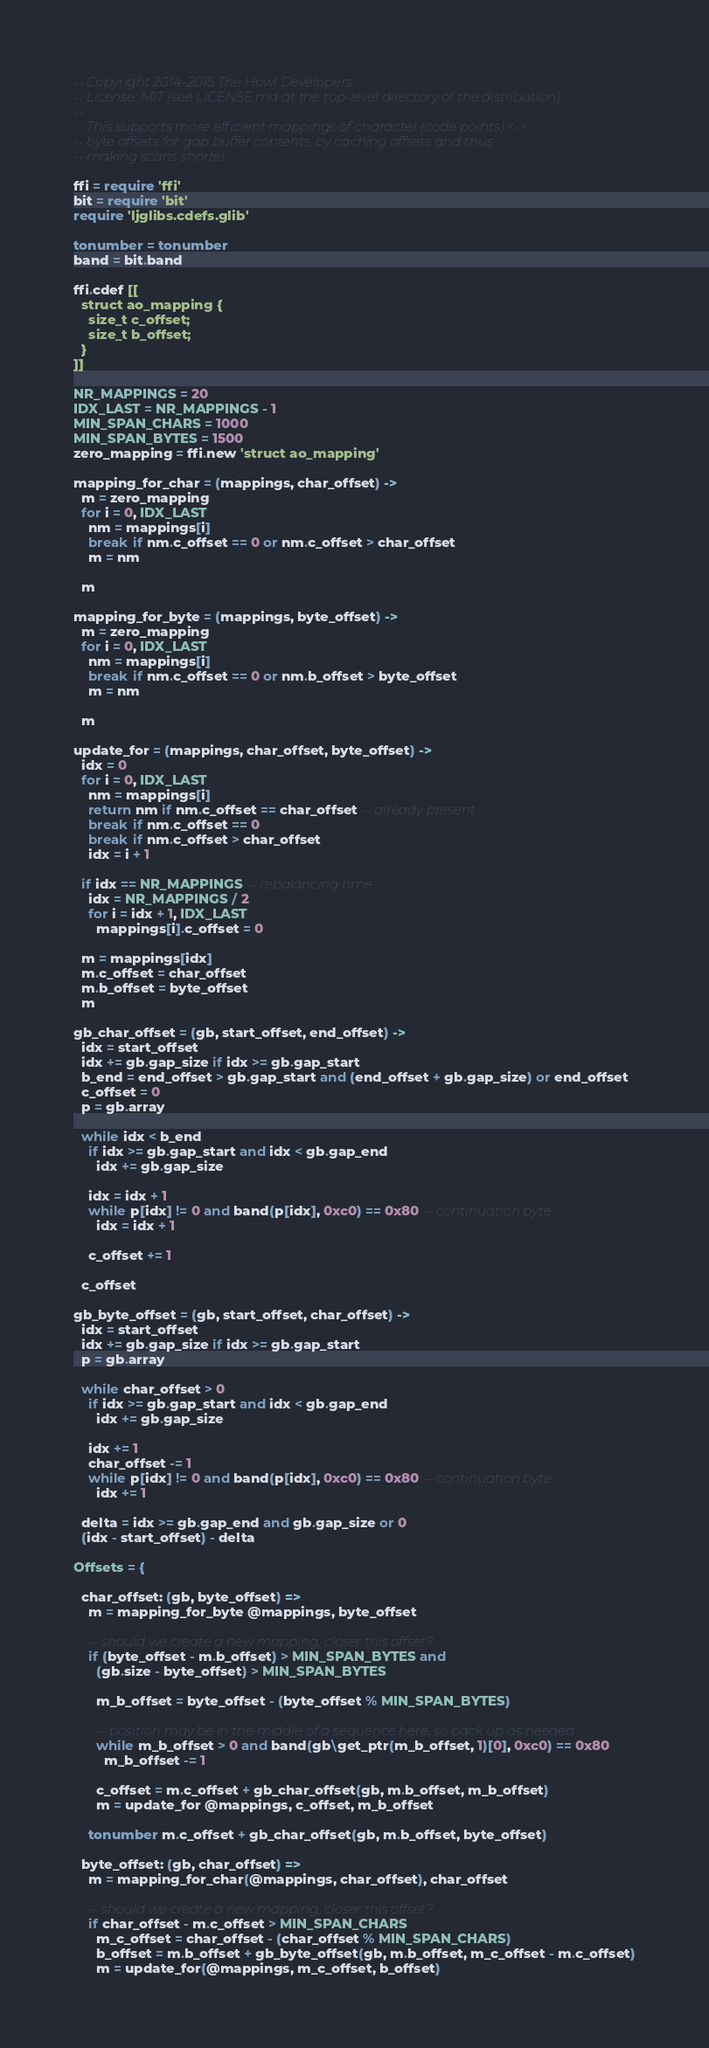<code> <loc_0><loc_0><loc_500><loc_500><_MoonScript_>-- Copyright 2014-2015 The Howl Developers
-- License: MIT (see LICENSE.md at the top-level directory of the distribution)
--
-- This supports more efficient mappings of character (code points) <->
-- byte offsets for gap buffer contents, by caching offsets and thus
-- making scans shorter

ffi = require 'ffi'
bit = require 'bit'
require 'ljglibs.cdefs.glib'

tonumber = tonumber
band = bit.band

ffi.cdef [[
  struct ao_mapping {
    size_t c_offset;
    size_t b_offset;
  }
]]

NR_MAPPINGS = 20
IDX_LAST = NR_MAPPINGS - 1
MIN_SPAN_CHARS = 1000
MIN_SPAN_BYTES = 1500
zero_mapping = ffi.new 'struct ao_mapping'

mapping_for_char = (mappings, char_offset) ->
  m = zero_mapping
  for i = 0, IDX_LAST
    nm = mappings[i]
    break if nm.c_offset == 0 or nm.c_offset > char_offset
    m = nm

  m

mapping_for_byte = (mappings, byte_offset) ->
  m = zero_mapping
  for i = 0, IDX_LAST
    nm = mappings[i]
    break if nm.c_offset == 0 or nm.b_offset > byte_offset
    m = nm

  m

update_for = (mappings, char_offset, byte_offset) ->
  idx = 0
  for i = 0, IDX_LAST
    nm = mappings[i]
    return nm if nm.c_offset == char_offset -- already present
    break if nm.c_offset == 0
    break if nm.c_offset > char_offset
    idx = i + 1

  if idx == NR_MAPPINGS -- rebalancing time
    idx = NR_MAPPINGS / 2
    for i = idx + 1, IDX_LAST
      mappings[i].c_offset = 0

  m = mappings[idx]
  m.c_offset = char_offset
  m.b_offset = byte_offset
  m

gb_char_offset = (gb, start_offset, end_offset) ->
  idx = start_offset
  idx += gb.gap_size if idx >= gb.gap_start
  b_end = end_offset > gb.gap_start and (end_offset + gb.gap_size) or end_offset
  c_offset = 0
  p = gb.array

  while idx < b_end
    if idx >= gb.gap_start and idx < gb.gap_end
      idx += gb.gap_size

    idx = idx + 1
    while p[idx] != 0 and band(p[idx], 0xc0) == 0x80 -- continuation byte
      idx = idx + 1

    c_offset += 1

  c_offset

gb_byte_offset = (gb, start_offset, char_offset) ->
  idx = start_offset
  idx += gb.gap_size if idx >= gb.gap_start
  p = gb.array

  while char_offset > 0
    if idx >= gb.gap_start and idx < gb.gap_end
      idx += gb.gap_size

    idx += 1
    char_offset -= 1
    while p[idx] != 0 and band(p[idx], 0xc0) == 0x80 -- continuation byte
      idx += 1

  delta = idx >= gb.gap_end and gb.gap_size or 0
  (idx - start_offset) - delta

Offsets = {

  char_offset: (gb, byte_offset) =>
    m = mapping_for_byte @mappings, byte_offset

    -- should we create a new mapping, closer this offset?
    if (byte_offset - m.b_offset) > MIN_SPAN_BYTES and
      (gb.size - byte_offset) > MIN_SPAN_BYTES

      m_b_offset = byte_offset - (byte_offset % MIN_SPAN_BYTES)

      -- position may be in the middle of a sequence here, so back up as needed
      while m_b_offset > 0 and band(gb\get_ptr(m_b_offset, 1)[0], 0xc0) == 0x80
        m_b_offset -= 1

      c_offset = m.c_offset + gb_char_offset(gb, m.b_offset, m_b_offset)
      m = update_for @mappings, c_offset, m_b_offset

    tonumber m.c_offset + gb_char_offset(gb, m.b_offset, byte_offset)

  byte_offset: (gb, char_offset) =>
    m = mapping_for_char(@mappings, char_offset), char_offset

    -- should we create a new mapping, closer this offset?
    if char_offset - m.c_offset > MIN_SPAN_CHARS
      m_c_offset = char_offset - (char_offset % MIN_SPAN_CHARS)
      b_offset = m.b_offset + gb_byte_offset(gb, m.b_offset, m_c_offset - m.c_offset)
      m = update_for(@mappings, m_c_offset, b_offset)
</code> 